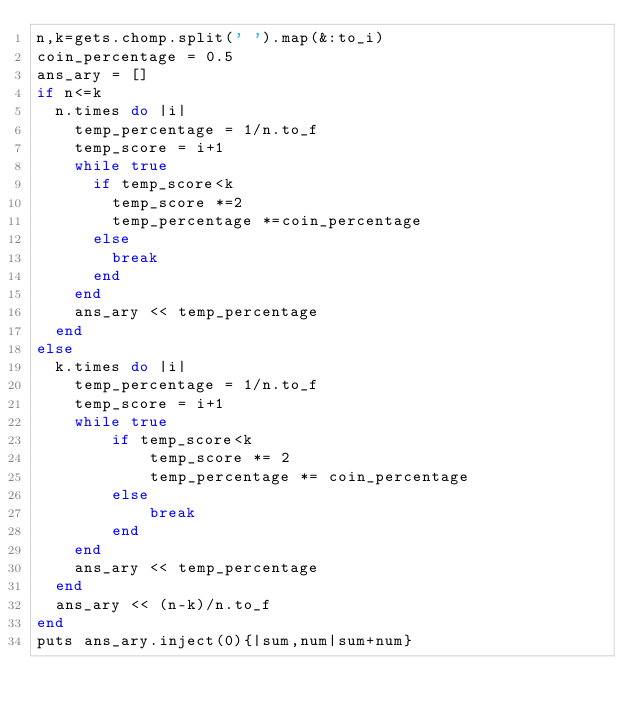<code> <loc_0><loc_0><loc_500><loc_500><_Ruby_>n,k=gets.chomp.split(' ').map(&:to_i)
coin_percentage = 0.5
ans_ary = []
if n<=k
  n.times do |i|
    temp_percentage = 1/n.to_f
    temp_score = i+1
    while true
      if temp_score<k
        temp_score *=2
        temp_percentage *=coin_percentage
      else
        break
      end
    end
    ans_ary << temp_percentage
  end
else
  k.times do |i|
    temp_percentage = 1/n.to_f
    temp_score = i+1
    while true
        if temp_score<k
            temp_score *= 2
            temp_percentage *= coin_percentage
        else
            break
        end
    end
    ans_ary << temp_percentage
  end
  ans_ary << (n-k)/n.to_f
end
puts ans_ary.inject(0){|sum,num|sum+num}</code> 